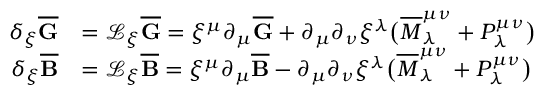Convert formula to latex. <formula><loc_0><loc_0><loc_500><loc_500>\begin{array} { r l } { \delta _ { \xi } \overline { G } } & { = \mathcal { L } _ { \xi } \overline { G } = \xi ^ { \mu } \partial _ { \mu } \overline { G } + \partial _ { \mu } \partial _ { \nu } \xi ^ { \lambda } \left ( \overline { M } ^ { \mu \nu } _ { \lambda } + P ^ { \mu \nu } _ { \lambda } \right ) } \\ { \delta _ { \xi } \overline { B } } & { = \mathcal { L } _ { \xi } \overline { B } = \xi ^ { \mu } \partial _ { \mu } \overline { B } - \partial _ { \mu } \partial _ { \nu } \xi ^ { \lambda } \left ( \overline { M } ^ { \mu \nu } _ { \lambda } + P ^ { \mu \nu } _ { \lambda } \right ) } \end{array}</formula> 